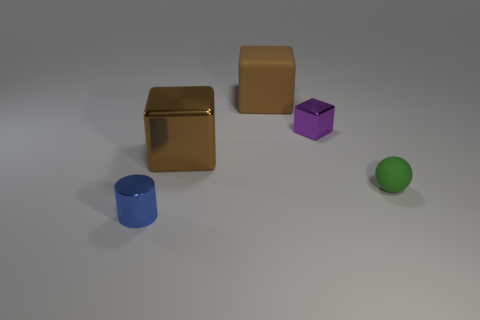What is the shape of the object behind the small metal object that is behind the small green sphere?
Your answer should be very brief. Cube. Is the color of the large rubber thing the same as the big metallic cube?
Your answer should be compact. Yes. How many blocks are either cyan metal objects or blue metal objects?
Provide a short and direct response. 0. There is a tiny thing that is both to the left of the matte sphere and in front of the tiny purple block; what is its material?
Provide a succinct answer. Metal. There is a large brown matte thing; what number of big brown matte blocks are behind it?
Ensure brevity in your answer.  0. Is the material of the brown cube behind the large brown metal object the same as the brown object in front of the small purple metal cube?
Your answer should be very brief. No. How many objects are tiny metallic things that are behind the small cylinder or red shiny things?
Give a very brief answer. 1. Is the number of tiny metal things in front of the purple shiny object less than the number of green rubber balls right of the green thing?
Offer a very short reply. No. What number of other objects are the same size as the rubber cube?
Keep it short and to the point. 1. Is the sphere made of the same material as the big object that is in front of the small cube?
Give a very brief answer. No. 